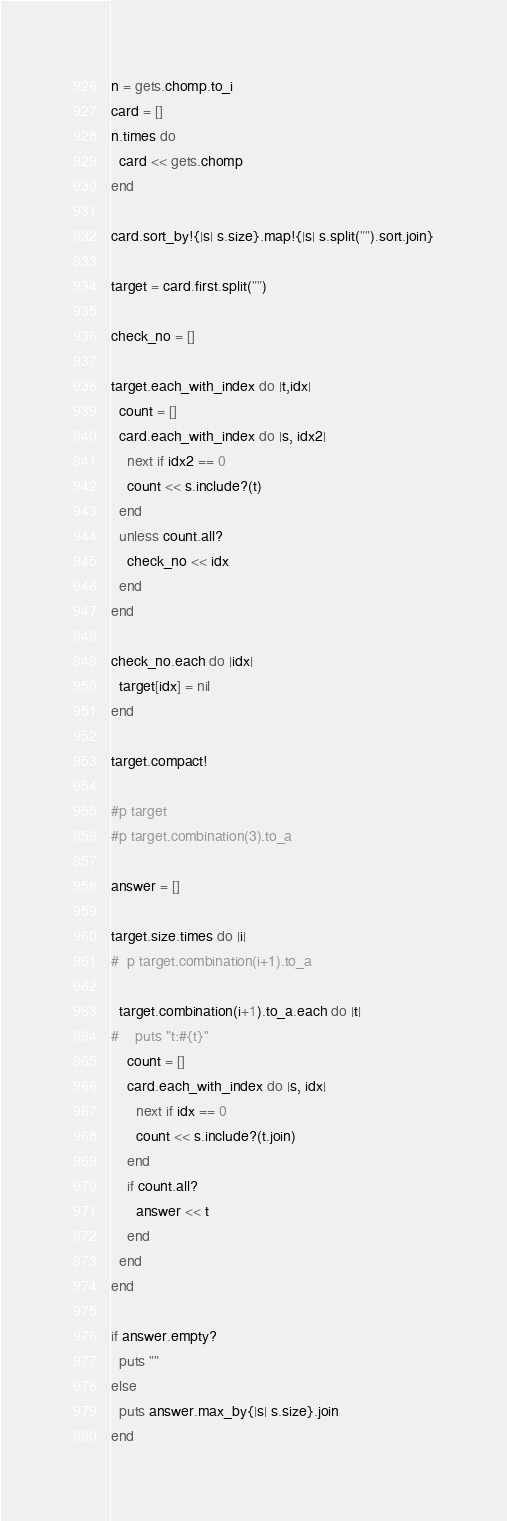<code> <loc_0><loc_0><loc_500><loc_500><_Ruby_>n = gets.chomp.to_i
card = []
n.times do
  card << gets.chomp
end

card.sort_by!{|s| s.size}.map!{|s| s.split("").sort.join}

target = card.first.split("")

check_no = []

target.each_with_index do |t,idx|
  count = []
  card.each_with_index do |s, idx2|
    next if idx2 == 0
    count << s.include?(t)
  end
  unless count.all?
    check_no << idx
  end
end

check_no.each do |idx|
  target[idx] = nil
end

target.compact!

#p target
#p target.combination(3).to_a

answer = []

target.size.times do |i|
#  p target.combination(i+1).to_a

  target.combination(i+1).to_a.each do |t|
#    puts "t:#{t}"
    count = []
    card.each_with_index do |s, idx|
      next if idx == 0
      count << s.include?(t.join)
    end
    if count.all?
      answer << t
    end
  end
end

if answer.empty?
  puts ""
else
  puts answer.max_by{|s| s.size}.join
end
</code> 